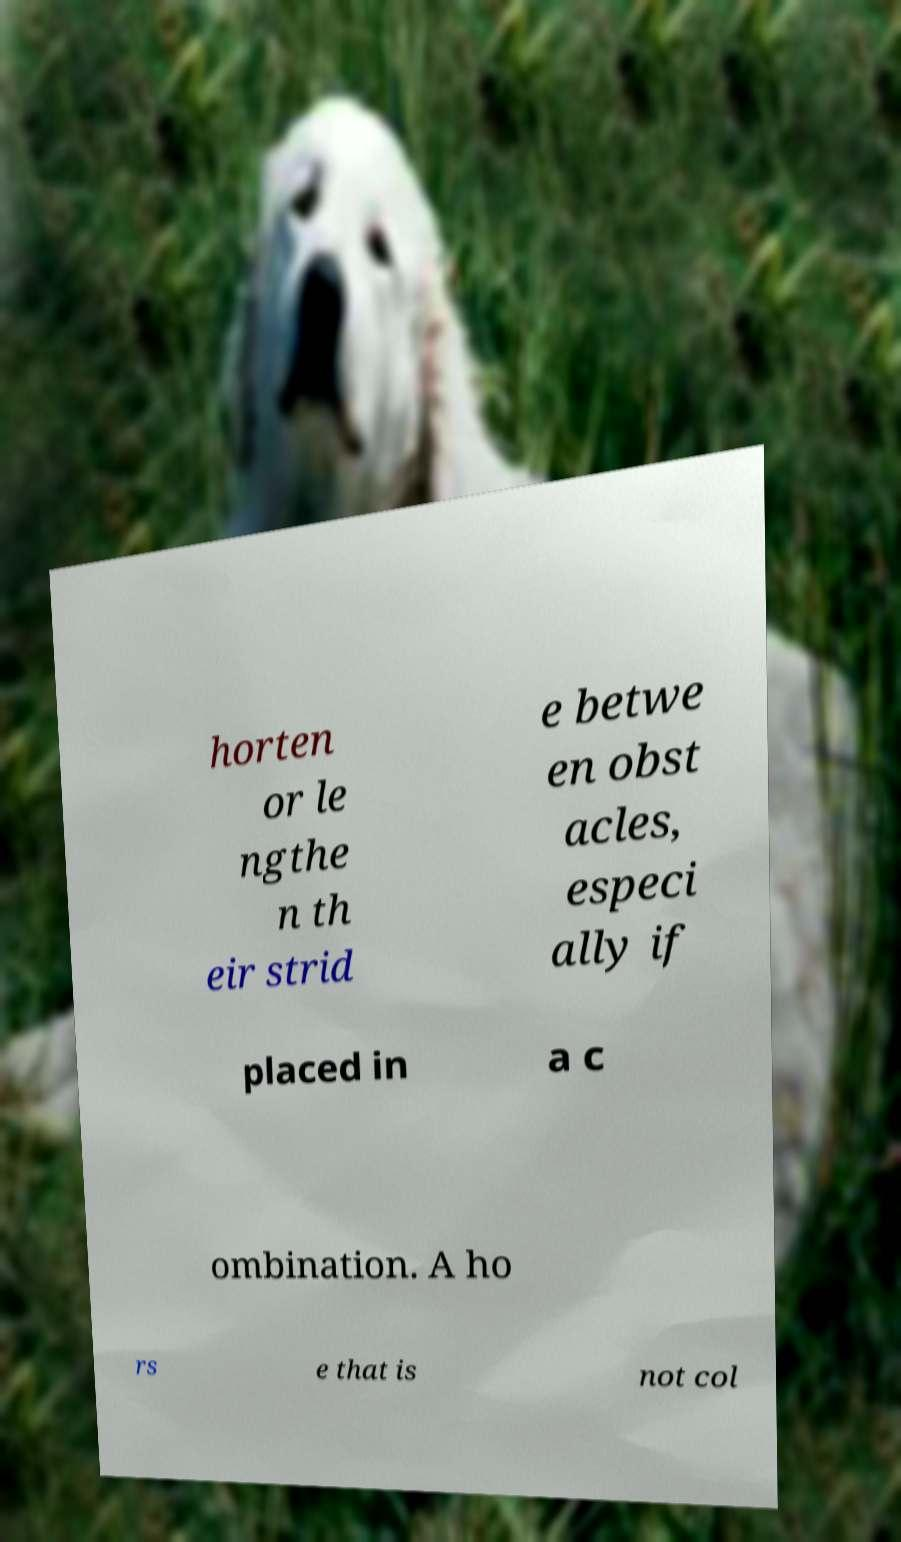Please identify and transcribe the text found in this image. horten or le ngthe n th eir strid e betwe en obst acles, especi ally if placed in a c ombination. A ho rs e that is not col 